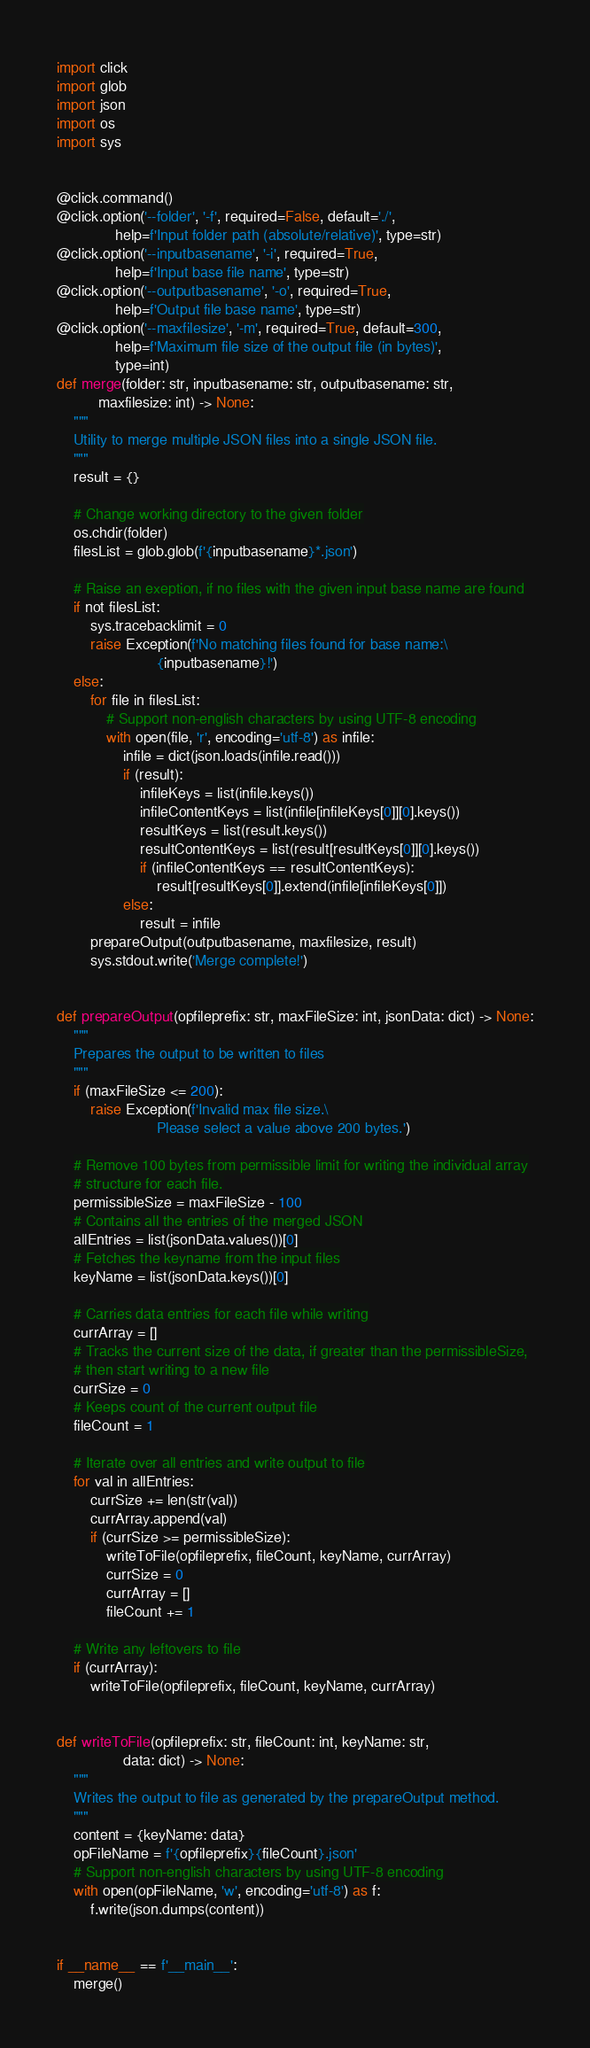Convert code to text. <code><loc_0><loc_0><loc_500><loc_500><_Python_>import click
import glob
import json
import os
import sys


@click.command()
@click.option('--folder', '-f', required=False, default='./',
              help=f'Input folder path (absolute/relative)', type=str)
@click.option('--inputbasename', '-i', required=True,
              help=f'Input base file name', type=str)
@click.option('--outputbasename', '-o', required=True,
              help=f'Output file base name', type=str)
@click.option('--maxfilesize', '-m', required=True, default=300,
              help=f'Maximum file size of the output file (in bytes)',
              type=int)
def merge(folder: str, inputbasename: str, outputbasename: str,
          maxfilesize: int) -> None:
    """
    Utility to merge multiple JSON files into a single JSON file.
    """
    result = {}

    # Change working directory to the given folder
    os.chdir(folder)
    filesList = glob.glob(f'{inputbasename}*.json')

    # Raise an exeption, if no files with the given input base name are found
    if not filesList:
        sys.tracebacklimit = 0
        raise Exception(f'No matching files found for base name:\
                        {inputbasename}!')
    else:
        for file in filesList:
            # Support non-english characters by using UTF-8 encoding
            with open(file, 'r', encoding='utf-8') as infile:
                infile = dict(json.loads(infile.read()))
                if (result):
                    infileKeys = list(infile.keys())
                    infileContentKeys = list(infile[infileKeys[0]][0].keys())
                    resultKeys = list(result.keys())
                    resultContentKeys = list(result[resultKeys[0]][0].keys())
                    if (infileContentKeys == resultContentKeys):
                        result[resultKeys[0]].extend(infile[infileKeys[0]])
                else:
                    result = infile
        prepareOutput(outputbasename, maxfilesize, result)
        sys.stdout.write('Merge complete!')


def prepareOutput(opfileprefix: str, maxFileSize: int, jsonData: dict) -> None:
    """
    Prepares the output to be written to files
    """
    if (maxFileSize <= 200):
        raise Exception(f'Invalid max file size.\
                        Please select a value above 200 bytes.')

    # Remove 100 bytes from permissible limit for writing the individual array
    # structure for each file.
    permissibleSize = maxFileSize - 100
    # Contains all the entries of the merged JSON
    allEntries = list(jsonData.values())[0]
    # Fetches the keyname from the input files
    keyName = list(jsonData.keys())[0]

    # Carries data entries for each file while writing
    currArray = []
    # Tracks the current size of the data, if greater than the permissibleSize,
    # then start writing to a new file
    currSize = 0
    # Keeps count of the current output file
    fileCount = 1

    # Iterate over all entries and write output to file
    for val in allEntries:
        currSize += len(str(val))
        currArray.append(val)
        if (currSize >= permissibleSize):
            writeToFile(opfileprefix, fileCount, keyName, currArray)
            currSize = 0
            currArray = []
            fileCount += 1

    # Write any leftovers to file
    if (currArray):
        writeToFile(opfileprefix, fileCount, keyName, currArray)


def writeToFile(opfileprefix: str, fileCount: int, keyName: str,
                data: dict) -> None:
    """
    Writes the output to file as generated by the prepareOutput method.
    """
    content = {keyName: data}
    opFileName = f'{opfileprefix}{fileCount}.json'
    # Support non-english characters by using UTF-8 encoding
    with open(opFileName, 'w', encoding='utf-8') as f:
        f.write(json.dumps(content))


if __name__ == f'__main__':
    merge()
</code> 